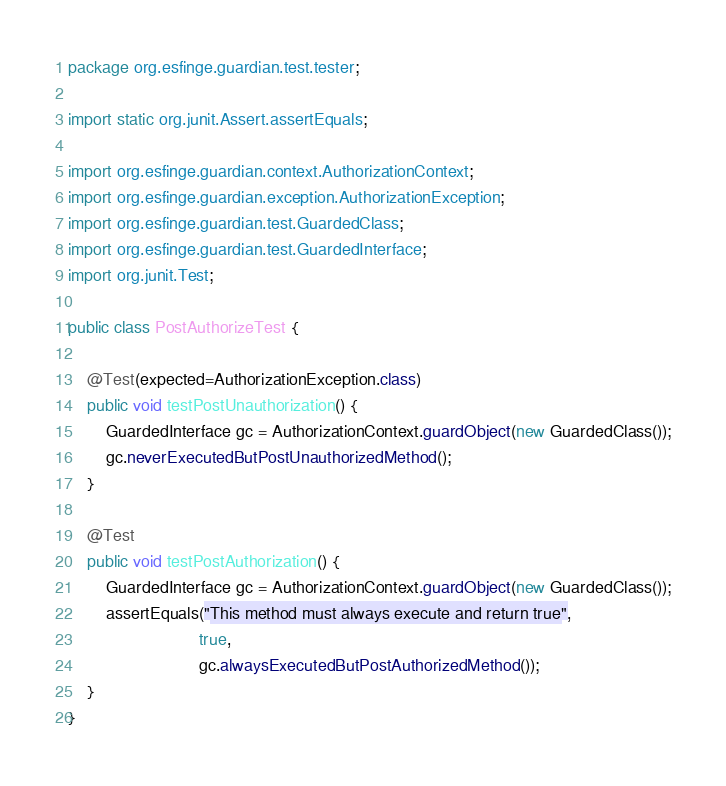<code> <loc_0><loc_0><loc_500><loc_500><_Java_>package org.esfinge.guardian.test.tester;

import static org.junit.Assert.assertEquals;

import org.esfinge.guardian.context.AuthorizationContext;
import org.esfinge.guardian.exception.AuthorizationException;
import org.esfinge.guardian.test.GuardedClass;
import org.esfinge.guardian.test.GuardedInterface;
import org.junit.Test;

public class PostAuthorizeTest {
	
	@Test(expected=AuthorizationException.class)
	public void testPostUnauthorization() {
		GuardedInterface gc = AuthorizationContext.guardObject(new GuardedClass());
		gc.neverExecutedButPostUnauthorizedMethod();
	}
	
	@Test
	public void testPostAuthorization() {
		GuardedInterface gc = AuthorizationContext.guardObject(new GuardedClass());
		assertEquals("This method must always execute and return true", 
							true, 
							gc.alwaysExecutedButPostAuthorizedMethod());
	}
}
</code> 